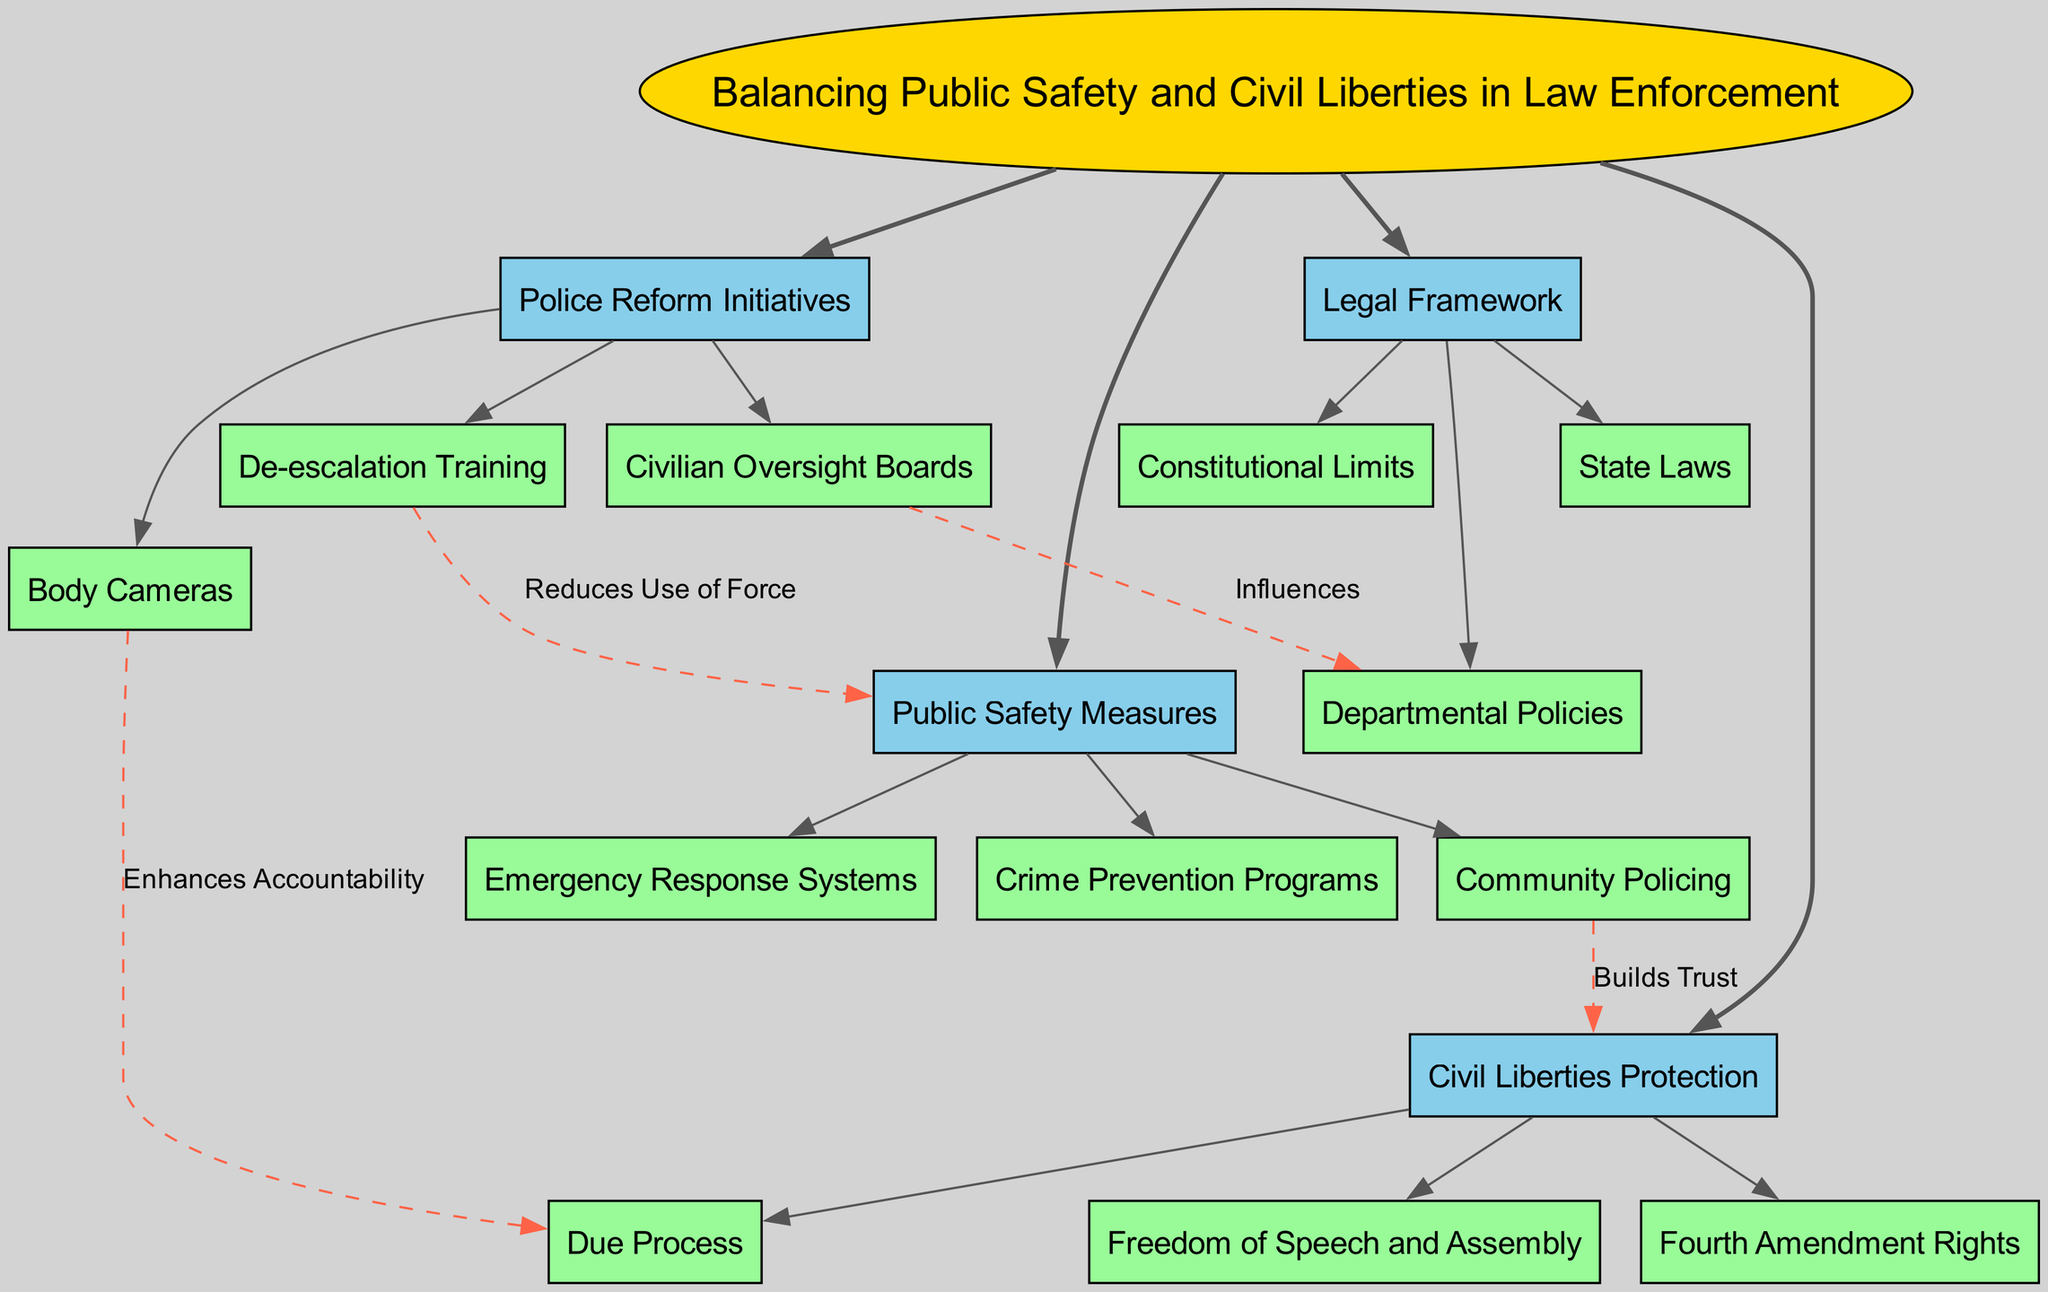What is the central concept of the diagram? The central concept of the diagram is explicitly stated at the center, which is "Balancing Public Safety and Civil Liberties in Law Enforcement". This is the main idea that connects all other elements depicted in the concept map.
Answer: Balancing Public Safety and Civil Liberties in Law Enforcement How many main branches are there? By counting the listed main branches in the diagram, there are four distinct branches: Public Safety Measures, Civil Liberties Protection, Police Reform Initiatives, and Legal Framework.
Answer: 4 What subnode is associated with 'Police Reform Initiatives'? The subnodes under 'Police Reform Initiatives' include De-escalation Training, Body Cameras, and Civilian Oversight Boards. When asked about any one of these subnodes, 'De-escalation Training' can be directly referenced as it is the first listed.
Answer: De-escalation Training What does Community Policing build with Civil Liberties Protection? According to the connection established in the diagram, Community Policing builds "Trust" with Civil Liberties Protection. This relationship highlights how community engagement can strengthen civil liberties.
Answer: Trust How does Body Cameras enhance Due Process? The diagram indicates that Body Cameras enhance Due Process by promoting "Accountability". This implies that having body cameras in use helps ensure that interactions are recorded and that due process is maintained.
Answer: Accountability What influences Departmental Policies according to the diagram? The diagram shows a connection where Civilian Oversight Boards influence Departmental Policies. This suggests that civilian oversight can impact how policies are formed and implemented within police departments.
Answer: Civilian Oversight Boards Which practice reduces the Use of Force in Public Safety Measures? The connection stated in the diagram illustrates that De-escalation Training is practiced to reduce the Use of Force in Public Safety Measures. This illustrates the practical approach to improving safety while protecting civil liberties.
Answer: De-escalation Training What are the constitutional limits mentioned in the Legal Framework? Although the diagram does not specify what the constitutional limits are, it indicates that they are a part of the Legal Framework. This implies they are foundational restrictions within law enforcement relevant to ensuring civil liberties.
Answer: Constitutional Limits 